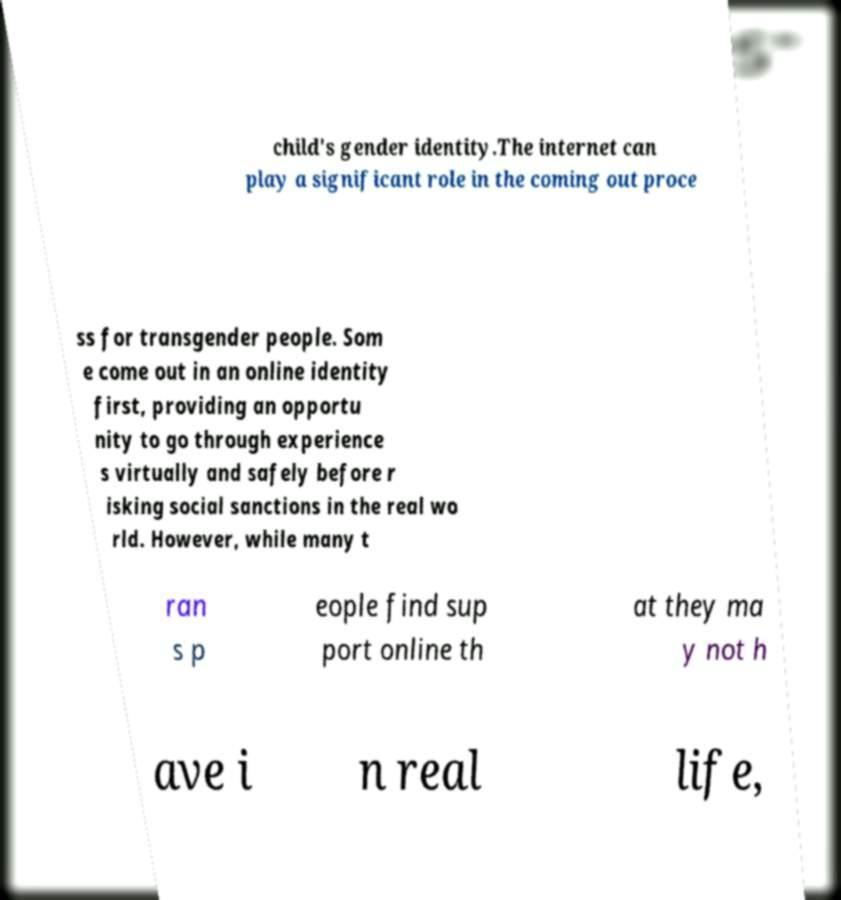Please identify and transcribe the text found in this image. child's gender identity.The internet can play a significant role in the coming out proce ss for transgender people. Som e come out in an online identity first, providing an opportu nity to go through experience s virtually and safely before r isking social sanctions in the real wo rld. However, while many t ran s p eople find sup port online th at they ma y not h ave i n real life, 